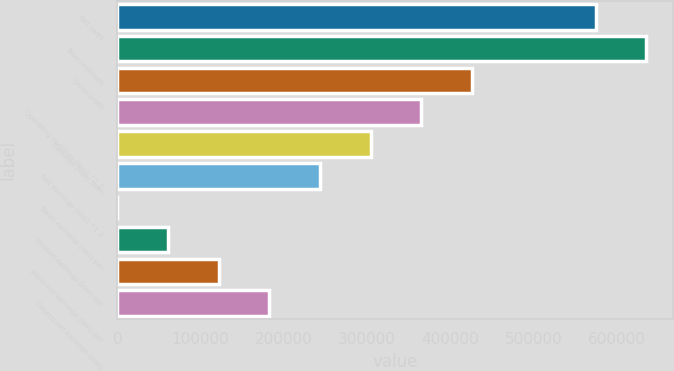<chart> <loc_0><loc_0><loc_500><loc_500><bar_chart><fcel>Net sales<fcel>Total revenues<fcel>Gross profit<fcel>Operating earnings (loss) ^1 2<fcel>Earnings (loss) from<fcel>Net earnings (loss) ^1 2<fcel>Basic earnings (loss) per<fcel>Diluted earnings (loss) per<fcel>Basic net earnings (loss) per<fcel>Diluted net earnings (loss)<nl><fcel>574886<fcel>635729<fcel>425902<fcel>365059<fcel>304216<fcel>243372<fcel>0.03<fcel>60843.1<fcel>121686<fcel>182529<nl></chart> 